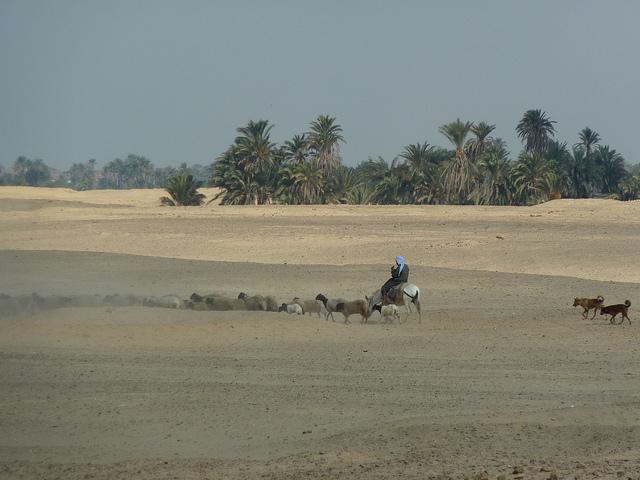How many types of animals are in the picture?
Give a very brief answer. 3. How many airplanes are present?
Give a very brief answer. 0. 